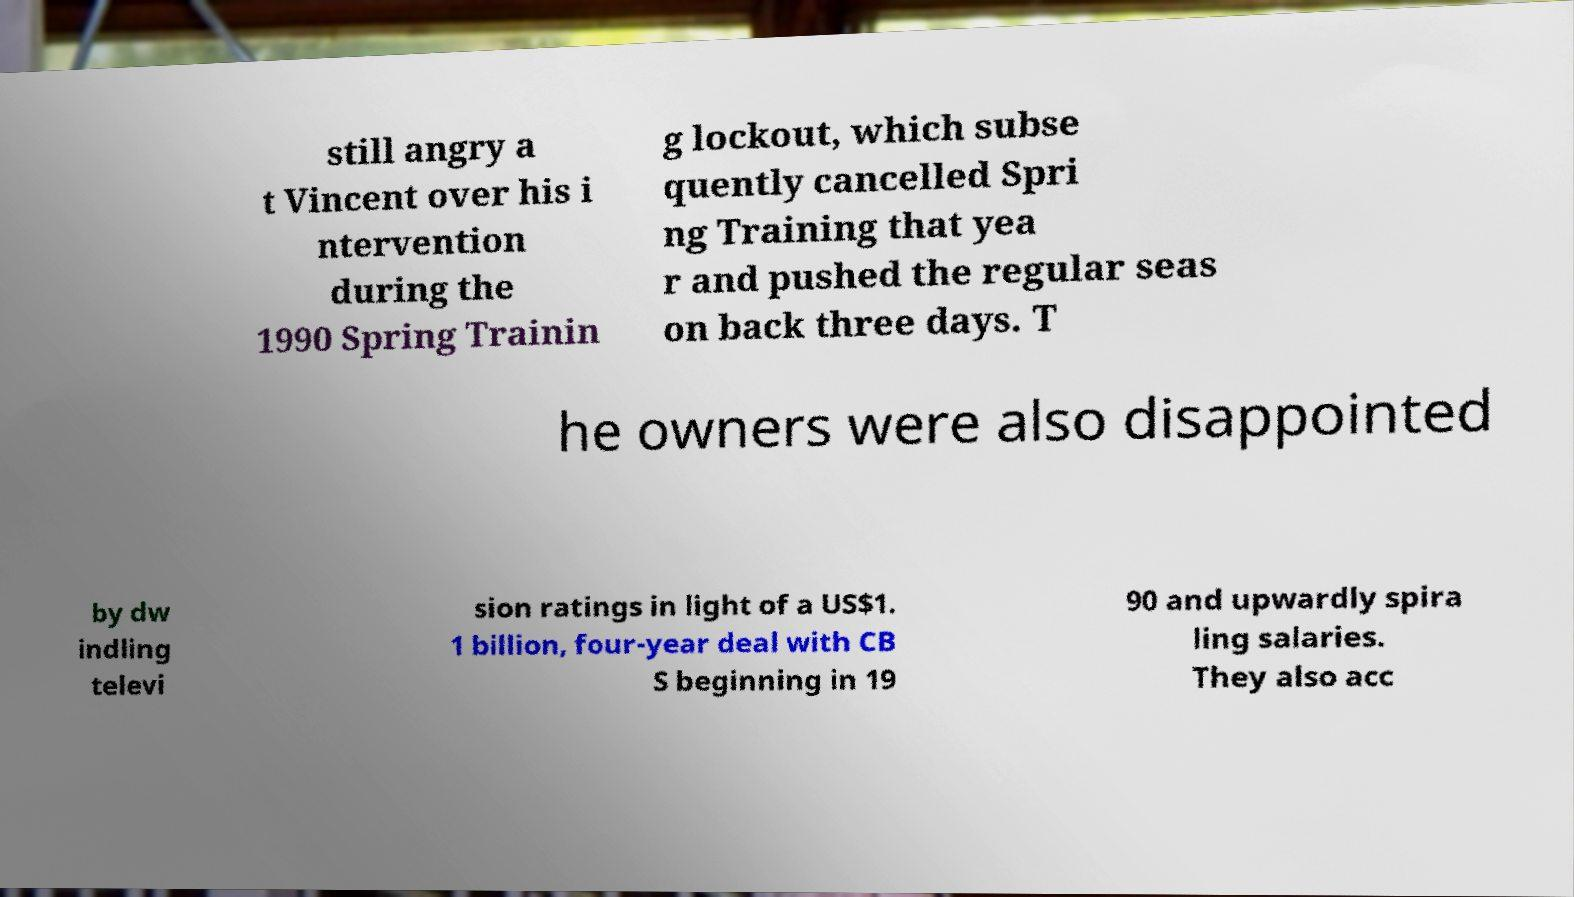Please identify and transcribe the text found in this image. still angry a t Vincent over his i ntervention during the 1990 Spring Trainin g lockout, which subse quently cancelled Spri ng Training that yea r and pushed the regular seas on back three days. T he owners were also disappointed by dw indling televi sion ratings in light of a US$1. 1 billion, four-year deal with CB S beginning in 19 90 and upwardly spira ling salaries. They also acc 